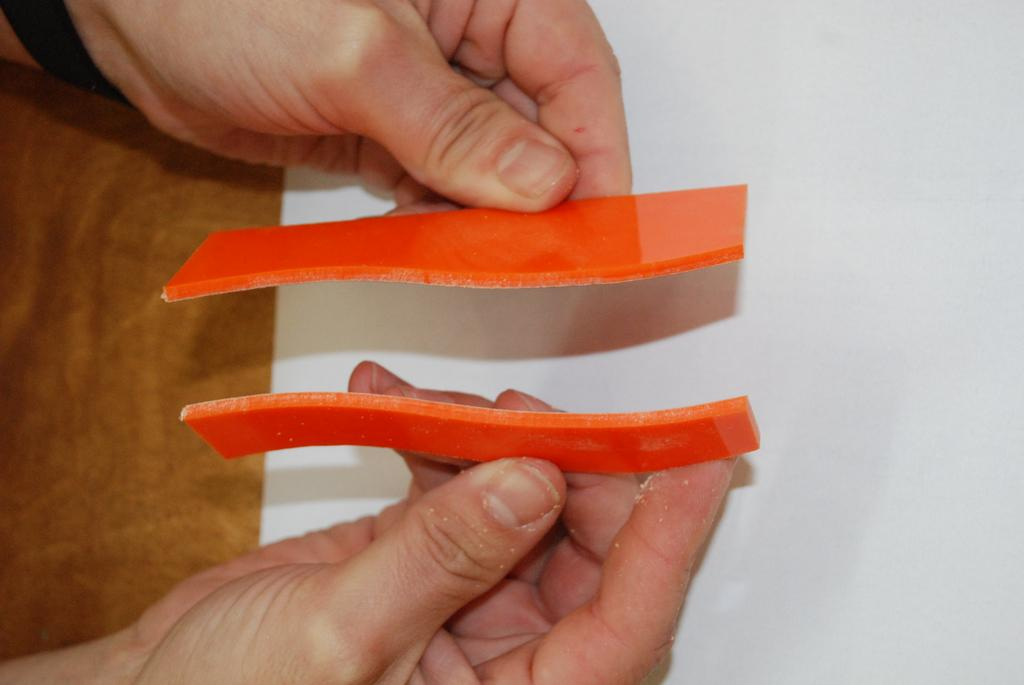What objects are made of orange plastic in the image? There are two orange pieces of plastic in the image. What is the relationship between the orange plastic objects and the human hands in the image? The orange pieces of plastic are being held by human hands. What type of furniture is present in the image? There is a brown and white desk in the image. What type of hook can be seen on the desk in the image? There is no hook present on the desk in the image. What role does the minister play in the image? There is no minister present in the image. 